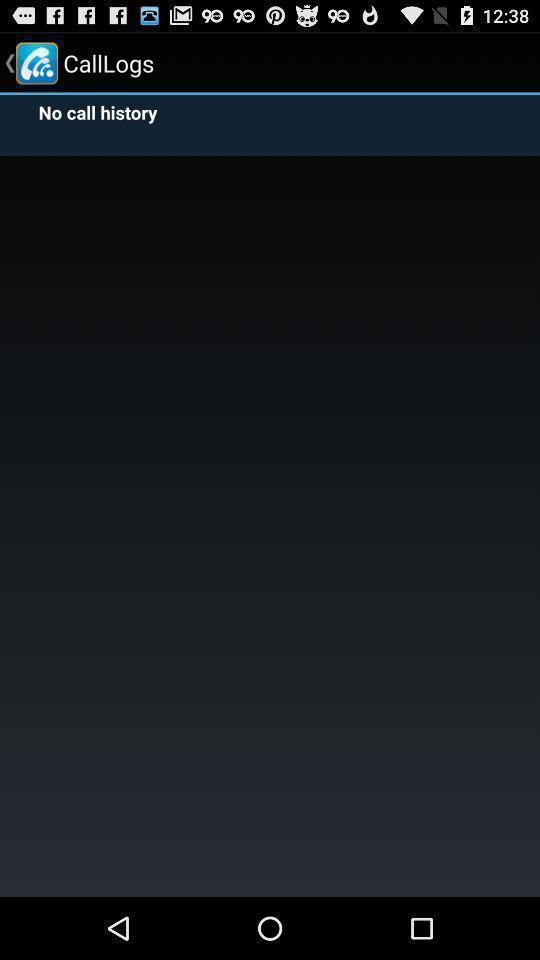Describe the content in this image. Page showing no call history in a call log. 